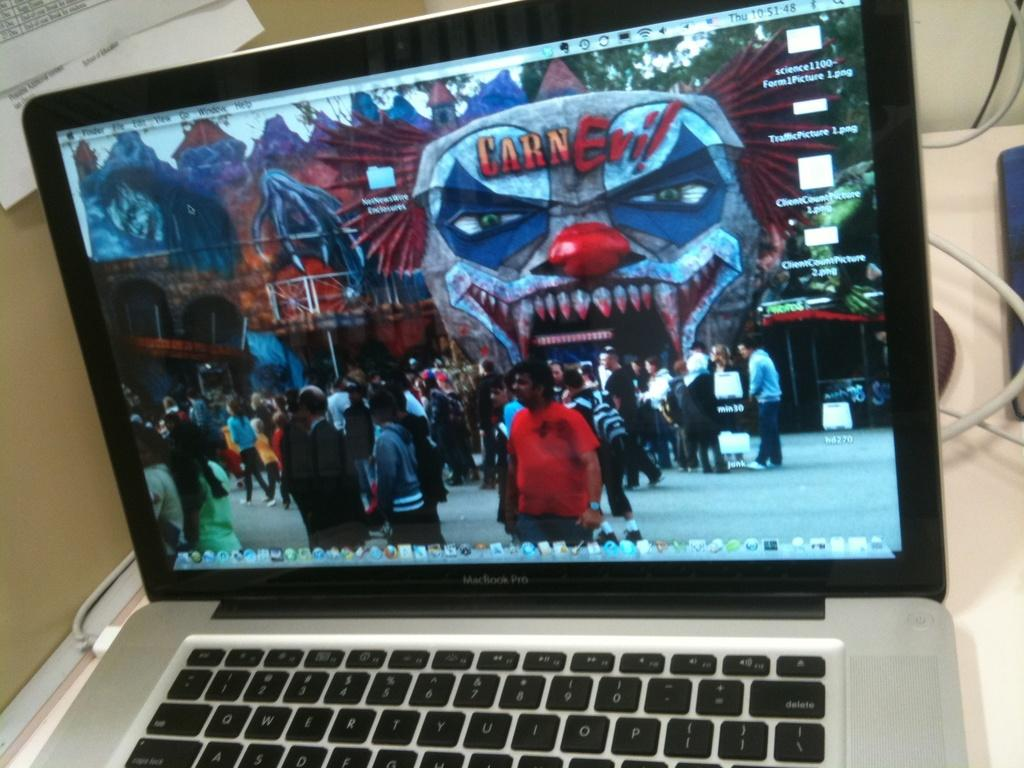<image>
Write a terse but informative summary of the picture. A laptop screen shows a scary clown face with CarnEvil on it. 